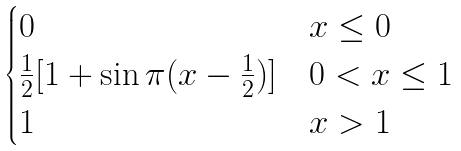Convert formula to latex. <formula><loc_0><loc_0><loc_500><loc_500>\begin{cases} 0 & { x \leq 0 } \\ \frac { 1 } { 2 } [ 1 + \sin \pi ( x - \frac { 1 } { 2 } ) ] & { 0 < x \leq 1 } \\ 1 & { x > 1 } \\ \end{cases}</formula> 